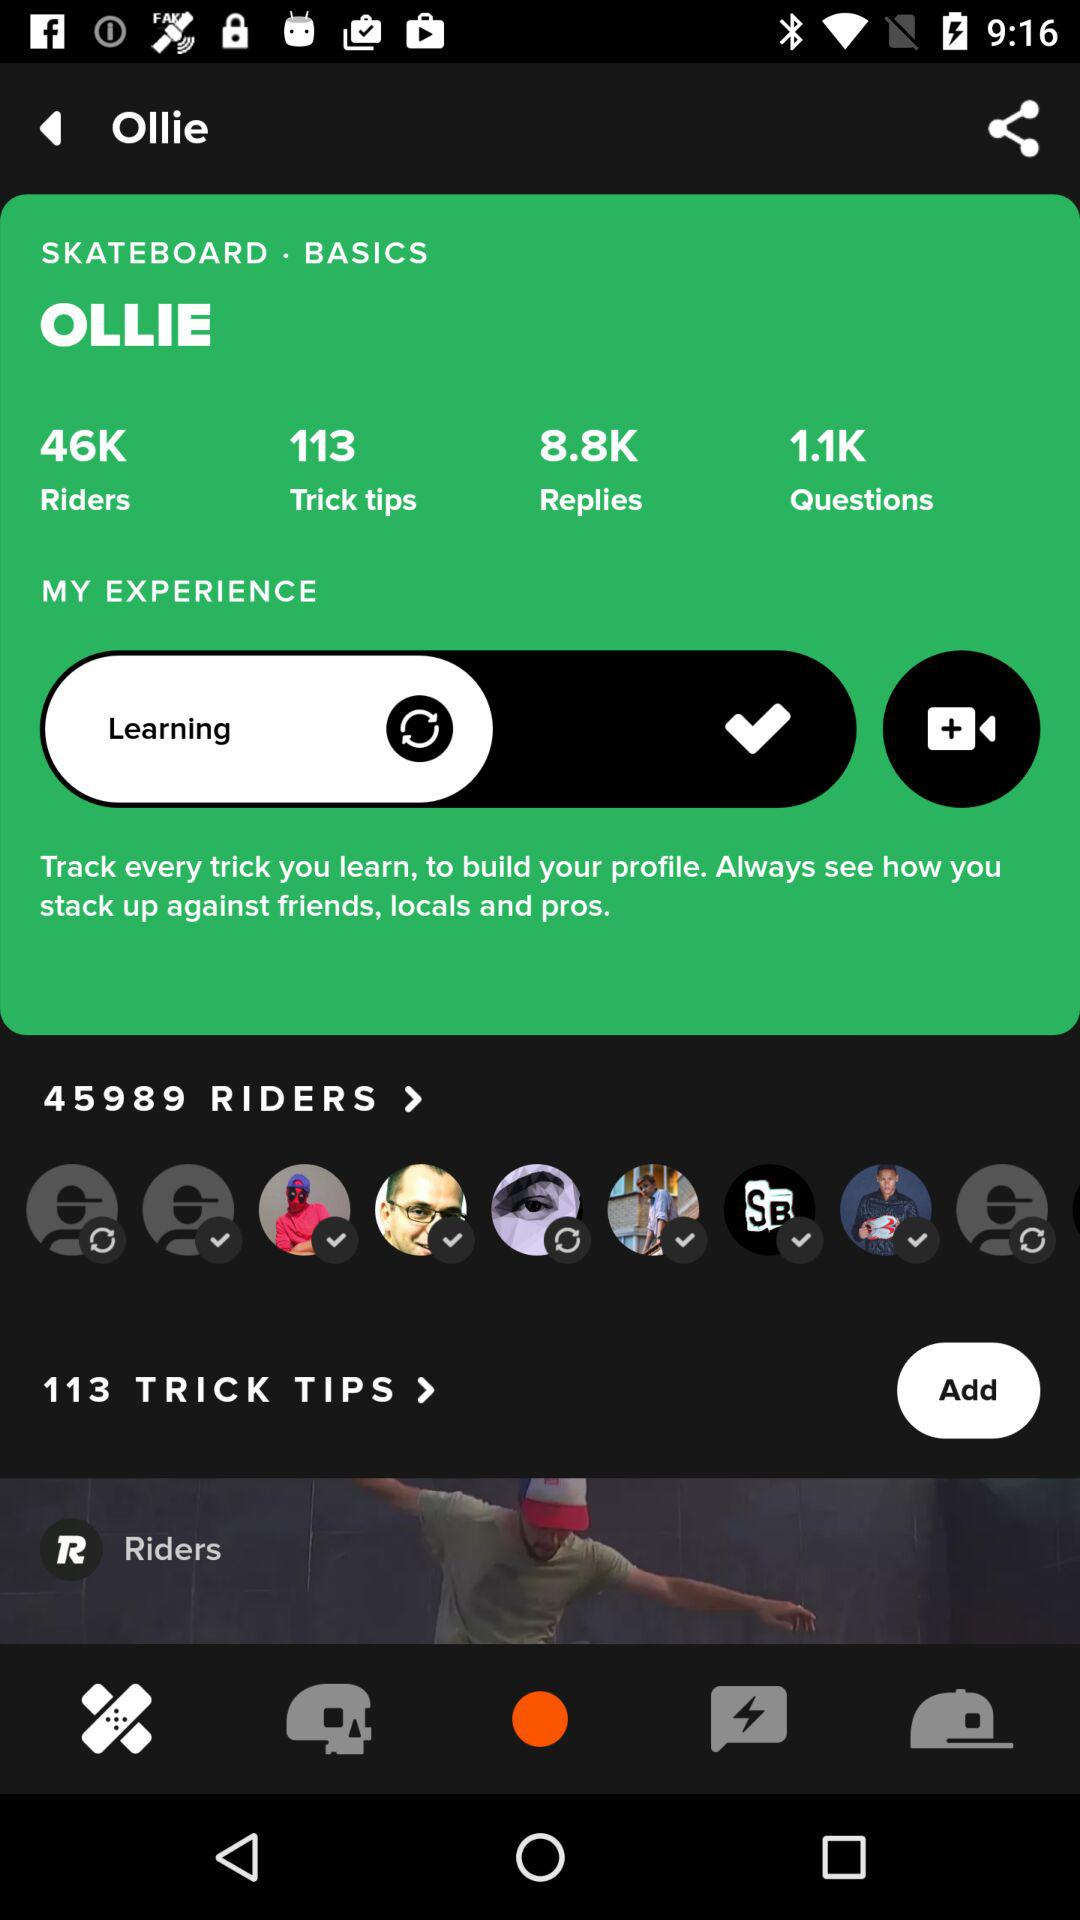How many more riders are there than trick tips?
Answer the question using a single word or phrase. 45876 